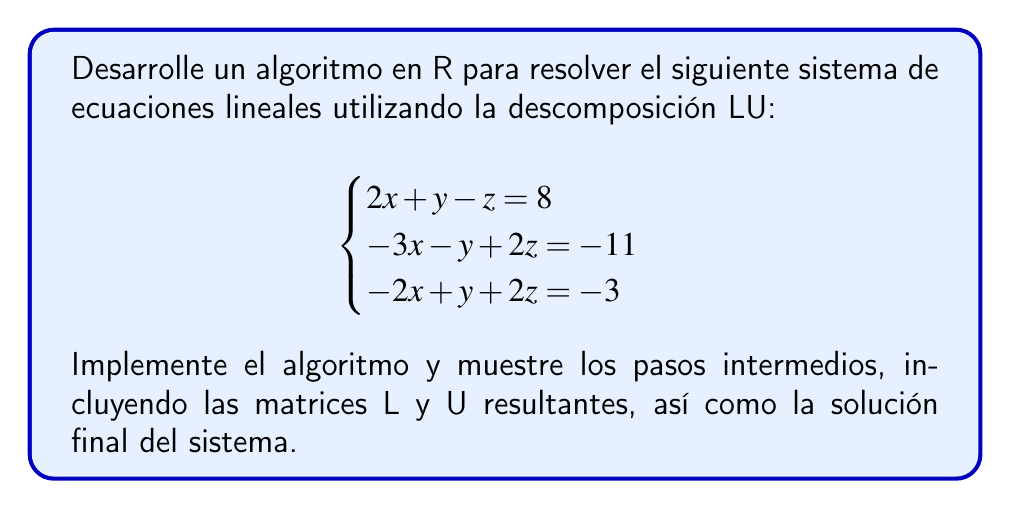What is the answer to this math problem? Para resolver este sistema usando descomposición LU en R, seguiremos estos pasos:

1) Primero, creamos la matriz A y el vector b:

```R
A <- matrix(c(2, 1, -1,
              -3, -1, 2,
              -2, 1, 2), nrow=3, byrow=TRUE)
b <- c(8, -11, -3)
```

2) Realizamos la descomposición LU:

```R
lu <- function(A) {
  n <- nrow(A)
  L <- diag(n)
  U <- A
  
  for (k in 1:(n-1)) {
    for (i in (k+1):n) {
      L[i,k] <- U[i,k] / U[k,k]
      U[i,k:n] <- U[i,k:n] - L[i,k] * U[k,k:n]
    }
  }
  
  list(L=L, U=U)
}

result <- lu(A)
L <- result$L
U <- result$U
```

3) Resolvemos Ly = b:

```R
y <- numeric(3)
y[1] <- b[1]
for (i in 2:3) {
  y[i] <- b[i] - sum(L[i,1:(i-1)] * y[1:(i-1)])
}
```

4) Resolvemos Ux = y:

```R
x <- numeric(3)
x[3] <- y[3] / U[3,3]
for (i in 2:1) {
  x[i] <- (y[i] - sum(U[i,(i+1):3] * x[(i+1):3])) / U[i,i]
}
```

Las matrices L y U resultantes son:

$$
L = \begin{pmatrix}
1 & 0 & 0 \\
-1.5 & 1 & 0 \\
-1 & 0 & 1
\end{pmatrix}
$$

$$
U = \begin{pmatrix}
2 & 1 & -1 \\
0 & -0.5 & 0.5 \\
0 & 0 & 1
\end{pmatrix}
$$

La solución final del sistema es: $x = 3$, $y = 4$, $z = 1$.
Answer: x = 3, y = 4, z = 1 